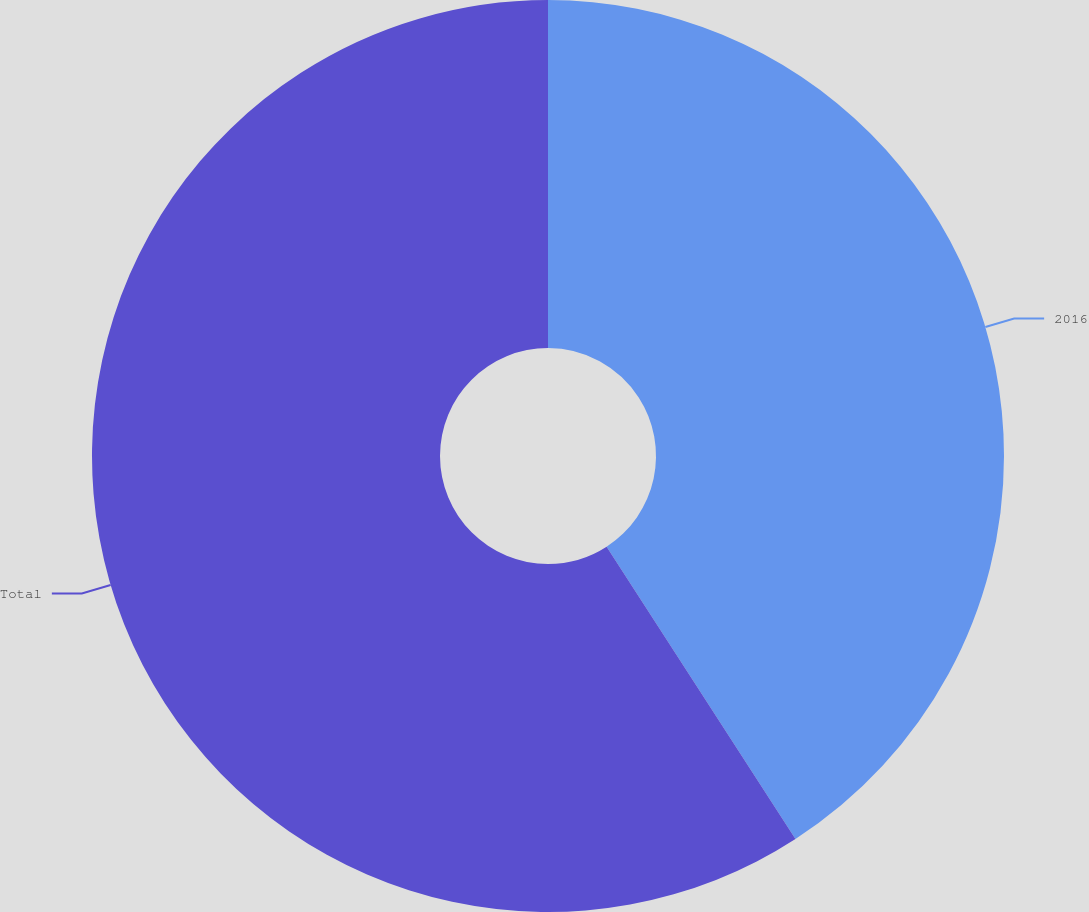<chart> <loc_0><loc_0><loc_500><loc_500><pie_chart><fcel>2016<fcel>Total<nl><fcel>40.87%<fcel>59.13%<nl></chart> 